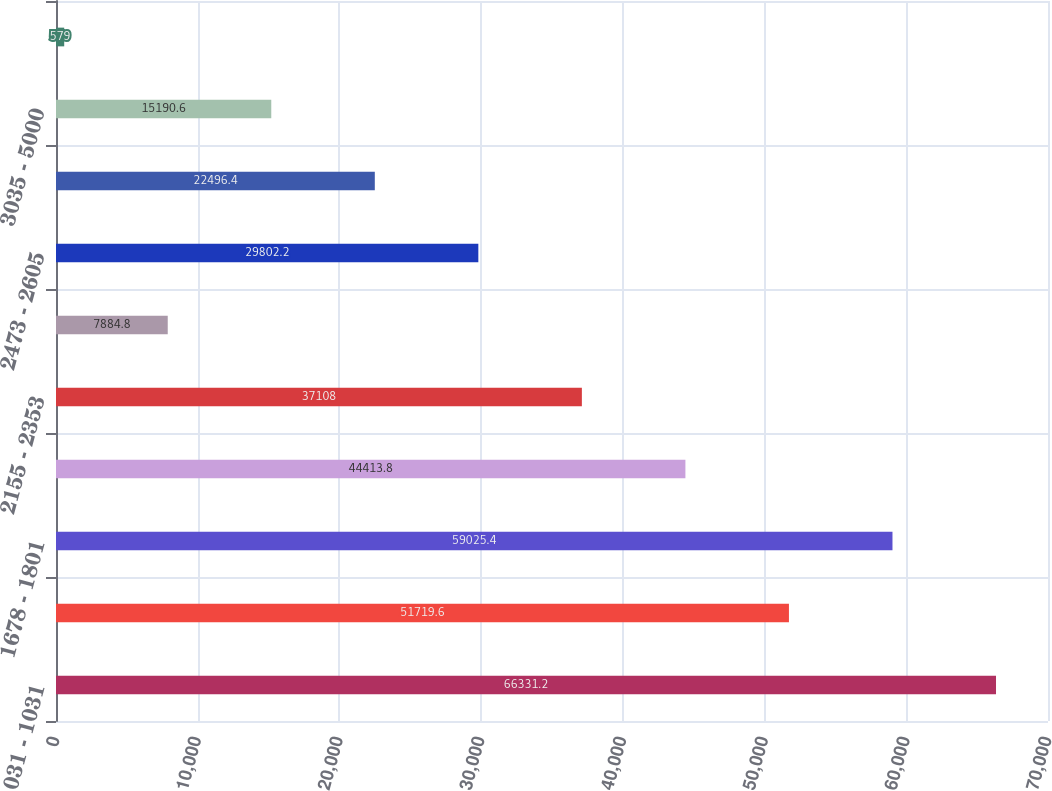Convert chart. <chart><loc_0><loc_0><loc_500><loc_500><bar_chart><fcel>031 - 1031<fcel>1054 - 1675<fcel>1678 - 1801<fcel>1803 - 2142<fcel>2155 - 2353<fcel>2369 - 2459<fcel>2473 - 2605<fcel>2609 - 3034<fcel>3035 - 5000<fcel>5129 - 18306<nl><fcel>66331.2<fcel>51719.6<fcel>59025.4<fcel>44413.8<fcel>37108<fcel>7884.8<fcel>29802.2<fcel>22496.4<fcel>15190.6<fcel>579<nl></chart> 